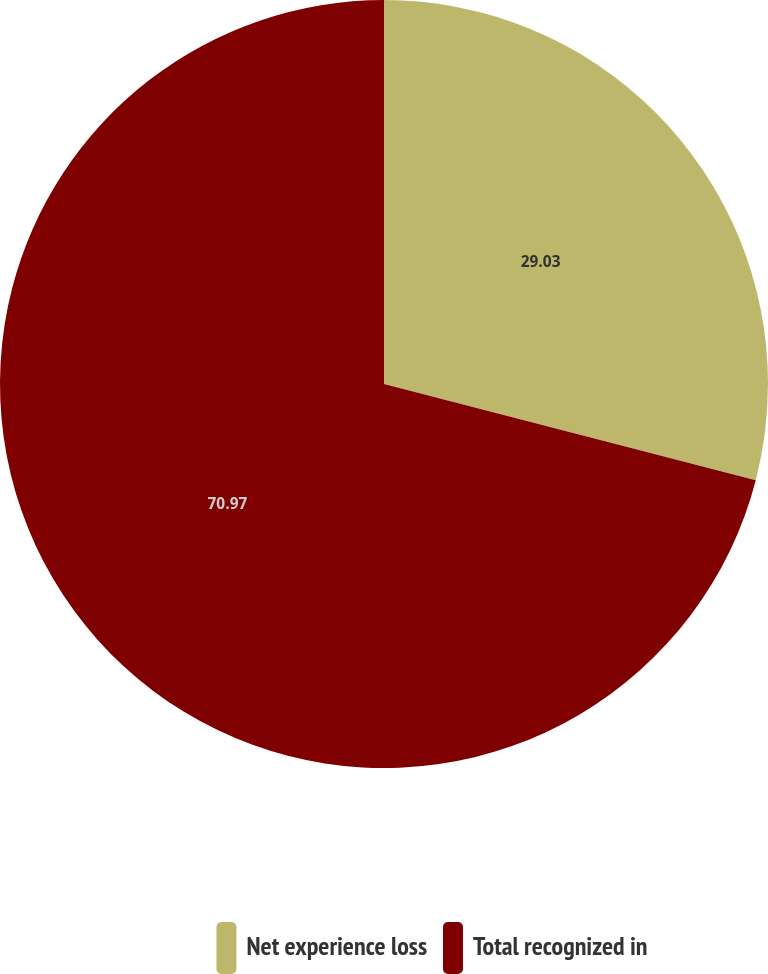Convert chart to OTSL. <chart><loc_0><loc_0><loc_500><loc_500><pie_chart><fcel>Net experience loss<fcel>Total recognized in<nl><fcel>29.03%<fcel>70.97%<nl></chart> 